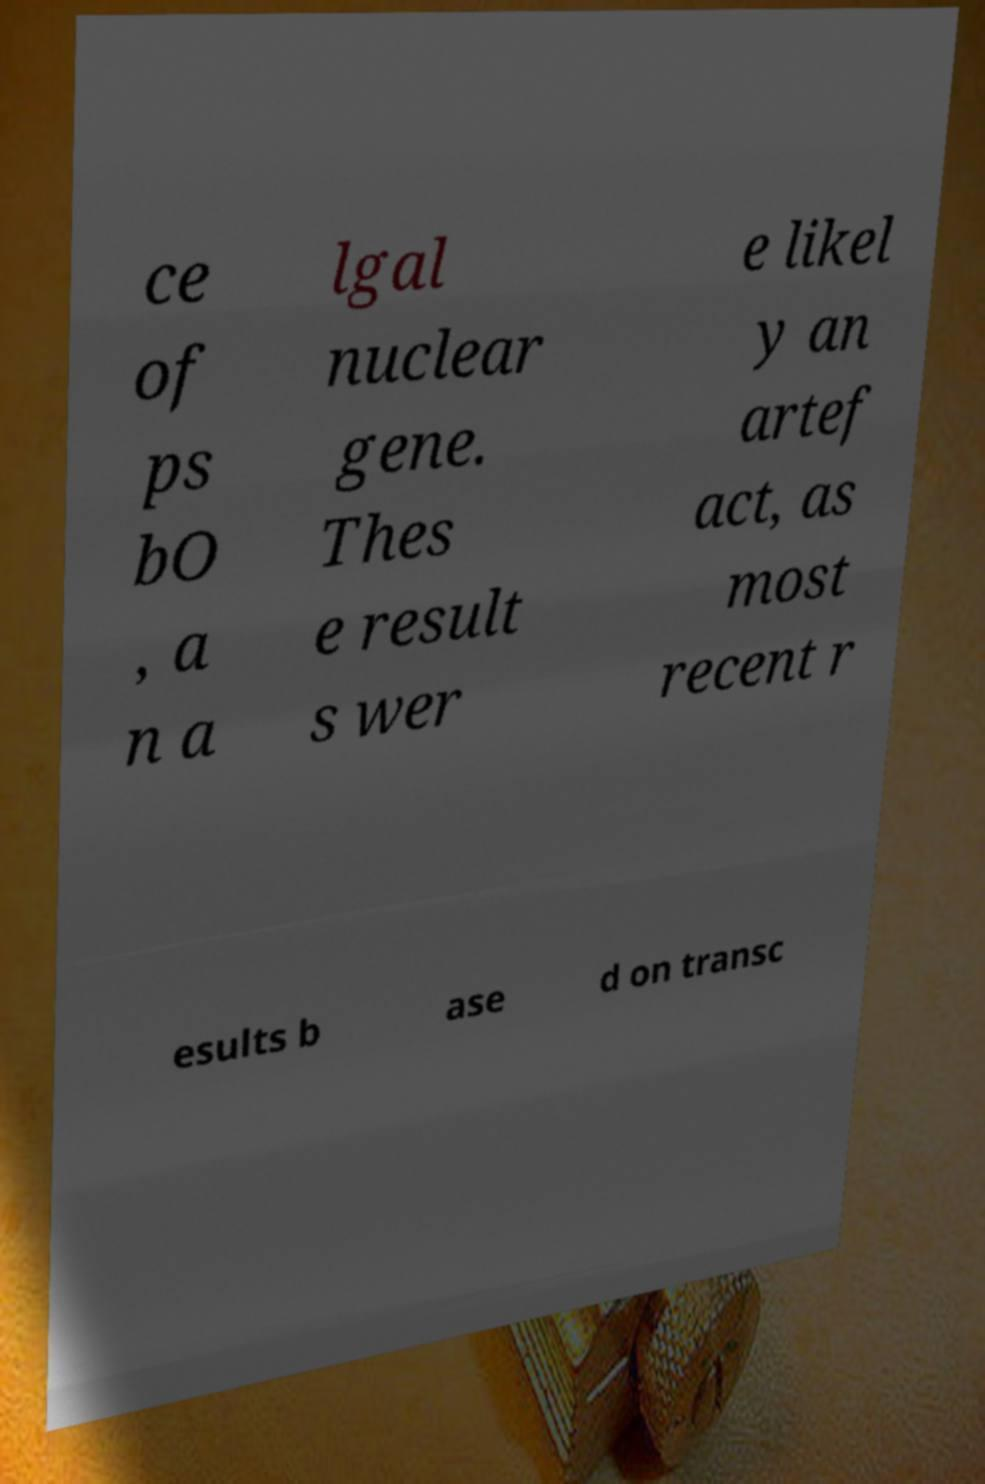What messages or text are displayed in this image? I need them in a readable, typed format. ce of ps bO , a n a lgal nuclear gene. Thes e result s wer e likel y an artef act, as most recent r esults b ase d on transc 